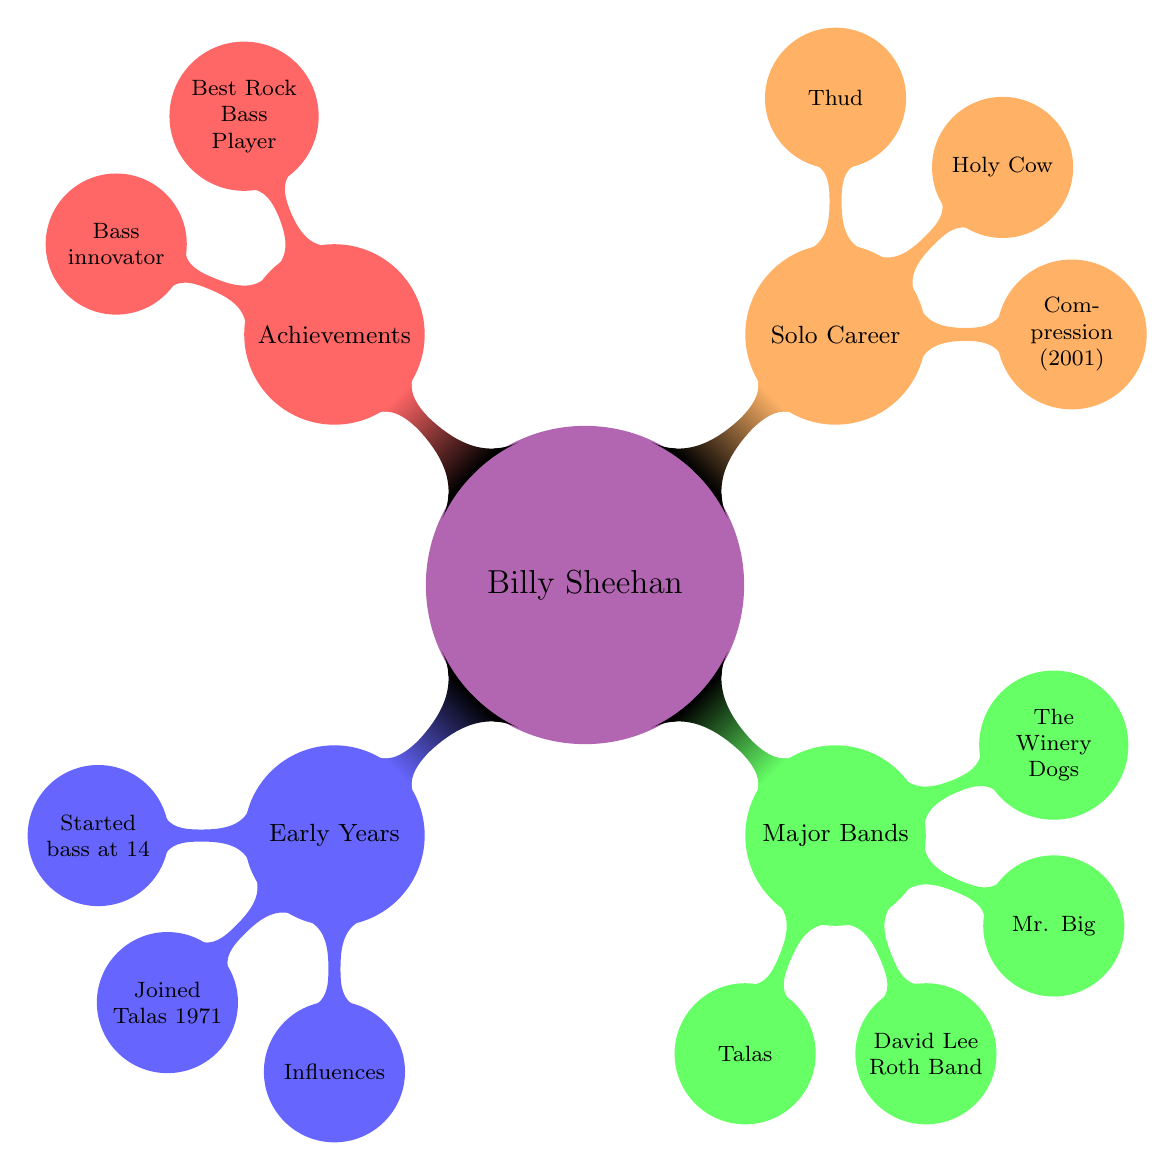What year did Billy Sheehan join Talas? The node connected to "Joined Talas" specifies "1971" as the year he joined the band.
Answer: 1971 What was Billy Sheehan's first solo album? The diagram indicates that "Compression" is his first solo album, released in 2001.
Answer: Compression Which band released the breakthrough album "Lean into It"? The node for "Mr. Big" states the breakthrough album "Lean into It" was released in 1991.
Answer: Mr. Big How many times did Billy Sheehan win the Bass Player magazine's 'Best Rock Bass Player' awards? The node under "Bass Player Of The Year" mentions that he won the award five times, summarizing his recognition in this category.
Answer: Five What major band did Billy Sheehan co-found in 2012? The node for "The Winery Dogs" indicates that he co-founded this band with Richie Kotzen and Mike Portnoy in the year 2012.
Answer: The Winery Dogs Which album was released by Mr. Big in 1991? The node related to "Mr. Big" states that "Lean into It" is the breakthrough album released in 1991.
Answer: Lean into It What instrument does Billy Sheehan play? Based on the entire mind map, it is evident that he is a bassist, as all milestones are related to his music career as a bassist.
Answer: Bass What influences did Billy Sheehan have according to the mind map? The "Influences" node lists "Jack Bruce" and "Tim Bogert", indicating the musicians who influenced his playing style.
Answer: Jack Bruce, Tim Bogert 